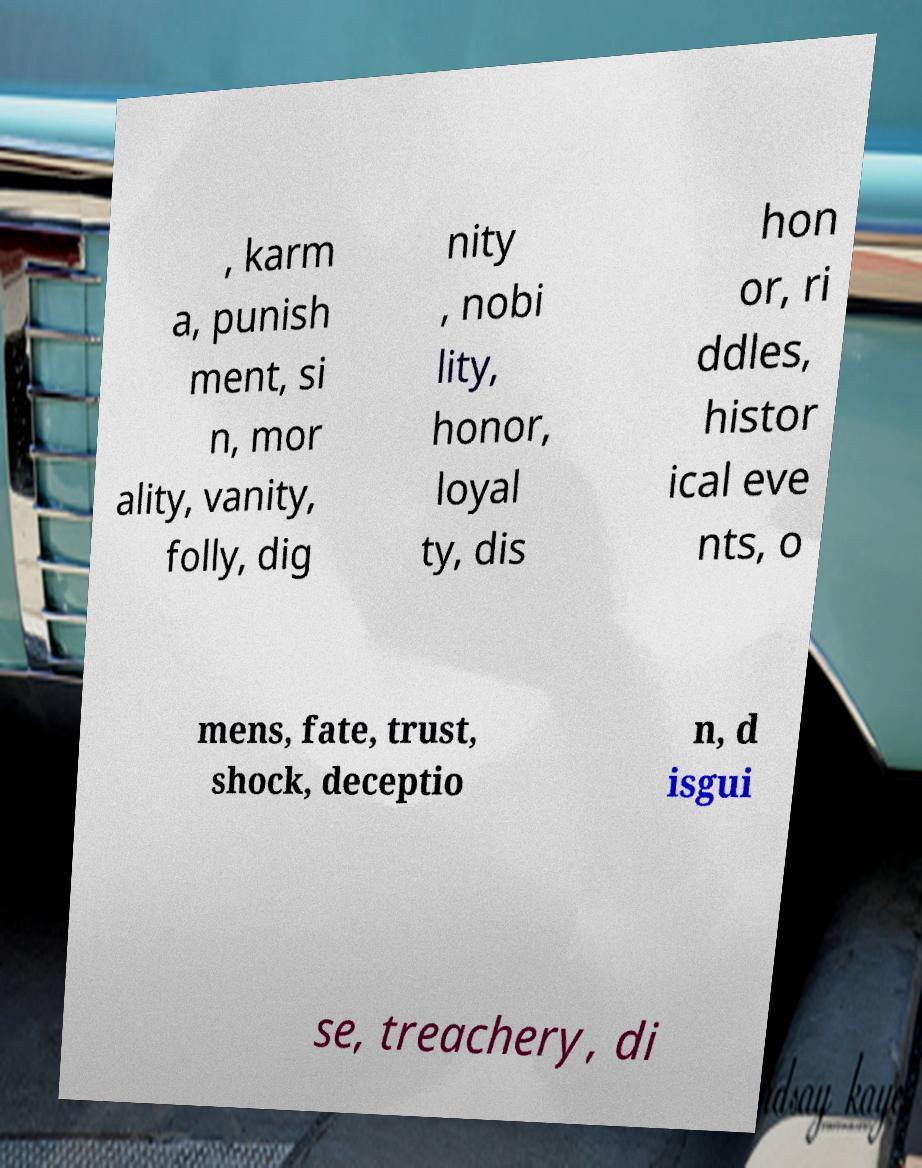Could you extract and type out the text from this image? , karm a, punish ment, si n, mor ality, vanity, folly, dig nity , nobi lity, honor, loyal ty, dis hon or, ri ddles, histor ical eve nts, o mens, fate, trust, shock, deceptio n, d isgui se, treachery, di 